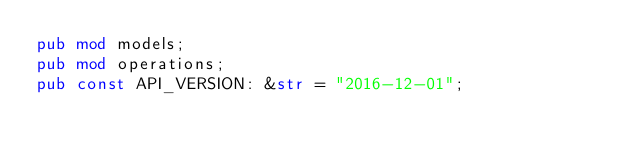<code> <loc_0><loc_0><loc_500><loc_500><_Rust_>pub mod models;
pub mod operations;
pub const API_VERSION: &str = "2016-12-01";
</code> 